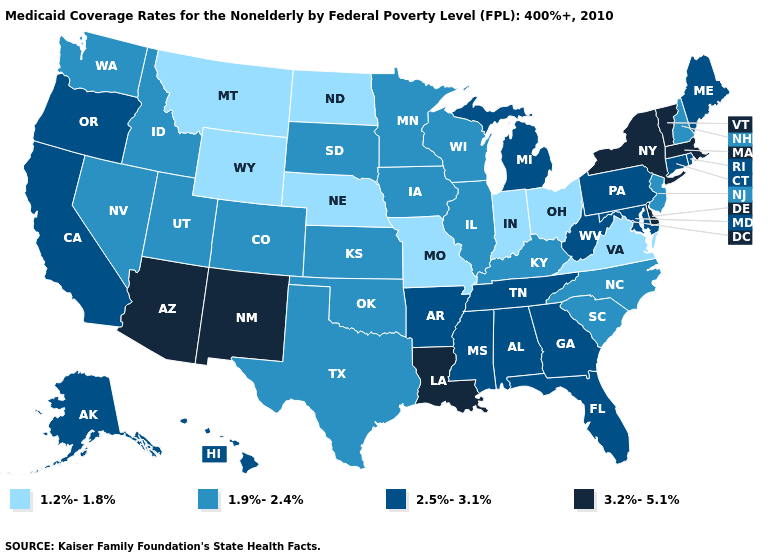Name the states that have a value in the range 1.2%-1.8%?
Answer briefly. Indiana, Missouri, Montana, Nebraska, North Dakota, Ohio, Virginia, Wyoming. What is the lowest value in states that border Wyoming?
Concise answer only. 1.2%-1.8%. Name the states that have a value in the range 1.9%-2.4%?
Be succinct. Colorado, Idaho, Illinois, Iowa, Kansas, Kentucky, Minnesota, Nevada, New Hampshire, New Jersey, North Carolina, Oklahoma, South Carolina, South Dakota, Texas, Utah, Washington, Wisconsin. What is the lowest value in the South?
Quick response, please. 1.2%-1.8%. What is the highest value in the Northeast ?
Quick response, please. 3.2%-5.1%. Among the states that border Oregon , does Nevada have the lowest value?
Short answer required. Yes. What is the highest value in states that border Oklahoma?
Short answer required. 3.2%-5.1%. Which states hav the highest value in the South?
Keep it brief. Delaware, Louisiana. Name the states that have a value in the range 3.2%-5.1%?
Short answer required. Arizona, Delaware, Louisiana, Massachusetts, New Mexico, New York, Vermont. What is the value of California?
Quick response, please. 2.5%-3.1%. Name the states that have a value in the range 1.9%-2.4%?
Give a very brief answer. Colorado, Idaho, Illinois, Iowa, Kansas, Kentucky, Minnesota, Nevada, New Hampshire, New Jersey, North Carolina, Oklahoma, South Carolina, South Dakota, Texas, Utah, Washington, Wisconsin. What is the lowest value in states that border Arizona?
Concise answer only. 1.9%-2.4%. Which states have the lowest value in the Northeast?
Be succinct. New Hampshire, New Jersey. Name the states that have a value in the range 1.2%-1.8%?
Short answer required. Indiana, Missouri, Montana, Nebraska, North Dakota, Ohio, Virginia, Wyoming. What is the highest value in states that border Minnesota?
Concise answer only. 1.9%-2.4%. 